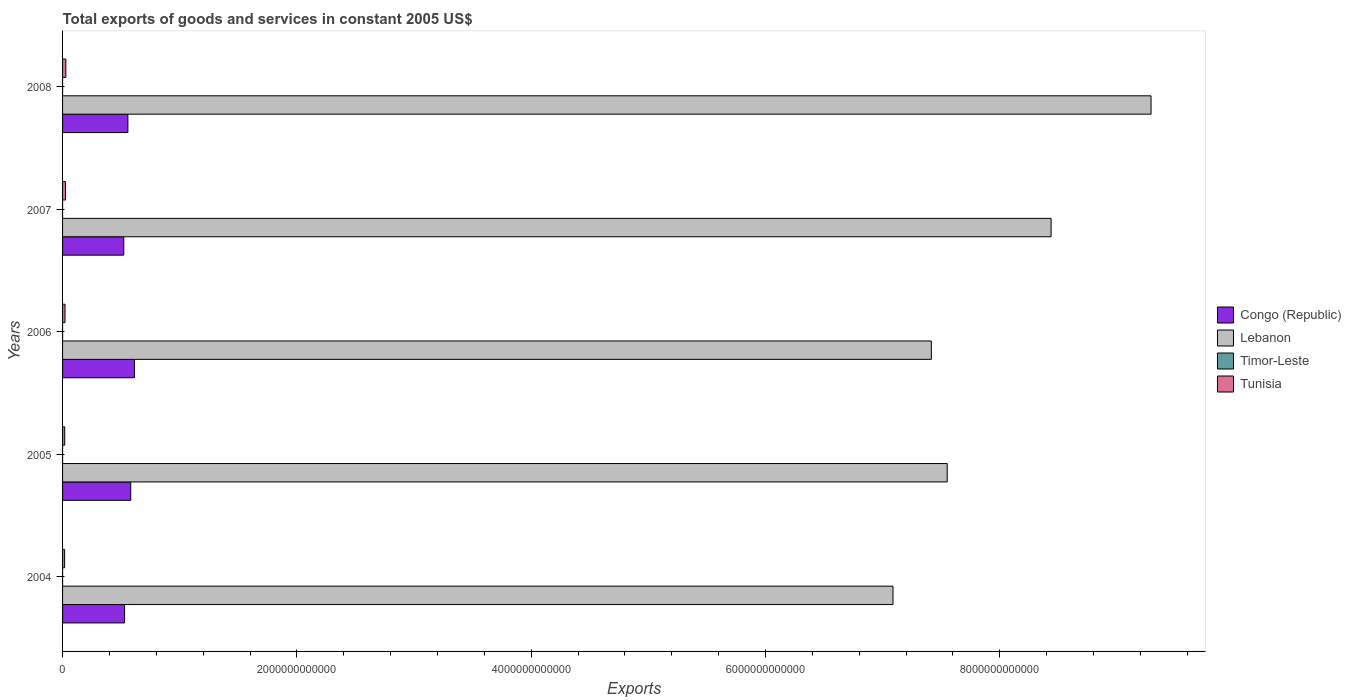How many bars are there on the 4th tick from the top?
Keep it short and to the point. 4. How many bars are there on the 2nd tick from the bottom?
Offer a very short reply. 4. What is the label of the 5th group of bars from the top?
Keep it short and to the point. 2004. What is the total exports of goods and services in Timor-Leste in 2008?
Offer a terse response. 6.50e+07. Across all years, what is the maximum total exports of goods and services in Tunisia?
Your answer should be very brief. 2.80e+1. Across all years, what is the minimum total exports of goods and services in Lebanon?
Ensure brevity in your answer.  7.09e+12. In which year was the total exports of goods and services in Congo (Republic) maximum?
Keep it short and to the point. 2006. In which year was the total exports of goods and services in Lebanon minimum?
Offer a terse response. 2004. What is the total total exports of goods and services in Lebanon in the graph?
Keep it short and to the point. 3.98e+13. What is the difference between the total exports of goods and services in Tunisia in 2007 and that in 2008?
Your answer should be compact. -2.82e+09. What is the difference between the total exports of goods and services in Tunisia in 2004 and the total exports of goods and services in Congo (Republic) in 2006?
Offer a terse response. -5.96e+11. What is the average total exports of goods and services in Timor-Leste per year?
Your answer should be very brief. 5.54e+07. In the year 2007, what is the difference between the total exports of goods and services in Congo (Republic) and total exports of goods and services in Tunisia?
Make the answer very short. 4.97e+11. What is the ratio of the total exports of goods and services in Tunisia in 2004 to that in 2007?
Your answer should be compact. 0.7. Is the difference between the total exports of goods and services in Congo (Republic) in 2004 and 2008 greater than the difference between the total exports of goods and services in Tunisia in 2004 and 2008?
Provide a short and direct response. No. What is the difference between the highest and the lowest total exports of goods and services in Congo (Republic)?
Offer a very short reply. 9.11e+1. In how many years, is the total exports of goods and services in Congo (Republic) greater than the average total exports of goods and services in Congo (Republic) taken over all years?
Offer a very short reply. 2. Is it the case that in every year, the sum of the total exports of goods and services in Lebanon and total exports of goods and services in Congo (Republic) is greater than the sum of total exports of goods and services in Timor-Leste and total exports of goods and services in Tunisia?
Give a very brief answer. Yes. What does the 2nd bar from the top in 2004 represents?
Provide a short and direct response. Timor-Leste. What does the 4th bar from the bottom in 2008 represents?
Your response must be concise. Tunisia. Are all the bars in the graph horizontal?
Offer a very short reply. Yes. What is the difference between two consecutive major ticks on the X-axis?
Ensure brevity in your answer.  2.00e+12. Are the values on the major ticks of X-axis written in scientific E-notation?
Ensure brevity in your answer.  No. Does the graph contain grids?
Provide a short and direct response. No. Where does the legend appear in the graph?
Ensure brevity in your answer.  Center right. How are the legend labels stacked?
Ensure brevity in your answer.  Vertical. What is the title of the graph?
Your answer should be very brief. Total exports of goods and services in constant 2005 US$. What is the label or title of the X-axis?
Offer a terse response. Exports. What is the label or title of the Y-axis?
Provide a succinct answer. Years. What is the Exports of Congo (Republic) in 2004?
Your answer should be compact. 5.29e+11. What is the Exports in Lebanon in 2004?
Keep it short and to the point. 7.09e+12. What is the Exports of Timor-Leste in 2004?
Keep it short and to the point. 5.10e+07. What is the Exports of Tunisia in 2004?
Provide a short and direct response. 1.75e+1. What is the Exports of Congo (Republic) in 2005?
Your response must be concise. 5.82e+11. What is the Exports in Lebanon in 2005?
Your response must be concise. 7.55e+12. What is the Exports in Timor-Leste in 2005?
Your response must be concise. 4.80e+07. What is the Exports of Tunisia in 2005?
Offer a very short reply. 1.83e+1. What is the Exports of Congo (Republic) in 2006?
Your response must be concise. 6.13e+11. What is the Exports in Lebanon in 2006?
Offer a terse response. 7.42e+12. What is the Exports of Timor-Leste in 2006?
Offer a terse response. 4.90e+07. What is the Exports in Tunisia in 2006?
Your answer should be compact. 2.10e+1. What is the Exports of Congo (Republic) in 2007?
Your answer should be compact. 5.22e+11. What is the Exports of Lebanon in 2007?
Make the answer very short. 8.44e+12. What is the Exports of Timor-Leste in 2007?
Offer a very short reply. 6.40e+07. What is the Exports of Tunisia in 2007?
Keep it short and to the point. 2.51e+1. What is the Exports in Congo (Republic) in 2008?
Offer a very short reply. 5.58e+11. What is the Exports in Lebanon in 2008?
Offer a terse response. 9.29e+12. What is the Exports of Timor-Leste in 2008?
Provide a short and direct response. 6.50e+07. What is the Exports of Tunisia in 2008?
Give a very brief answer. 2.80e+1. Across all years, what is the maximum Exports in Congo (Republic)?
Provide a succinct answer. 6.13e+11. Across all years, what is the maximum Exports of Lebanon?
Give a very brief answer. 9.29e+12. Across all years, what is the maximum Exports of Timor-Leste?
Keep it short and to the point. 6.50e+07. Across all years, what is the maximum Exports of Tunisia?
Offer a very short reply. 2.80e+1. Across all years, what is the minimum Exports of Congo (Republic)?
Offer a terse response. 5.22e+11. Across all years, what is the minimum Exports in Lebanon?
Ensure brevity in your answer.  7.09e+12. Across all years, what is the minimum Exports in Timor-Leste?
Your response must be concise. 4.80e+07. Across all years, what is the minimum Exports of Tunisia?
Offer a terse response. 1.75e+1. What is the total Exports in Congo (Republic) in the graph?
Offer a very short reply. 2.80e+12. What is the total Exports in Lebanon in the graph?
Your answer should be compact. 3.98e+13. What is the total Exports in Timor-Leste in the graph?
Your answer should be compact. 2.77e+08. What is the total Exports of Tunisia in the graph?
Provide a succinct answer. 1.10e+11. What is the difference between the Exports in Congo (Republic) in 2004 and that in 2005?
Give a very brief answer. -5.25e+1. What is the difference between the Exports in Lebanon in 2004 and that in 2005?
Your response must be concise. -4.63e+11. What is the difference between the Exports of Timor-Leste in 2004 and that in 2005?
Your response must be concise. 3.00e+06. What is the difference between the Exports of Tunisia in 2004 and that in 2005?
Keep it short and to the point. -7.73e+08. What is the difference between the Exports in Congo (Republic) in 2004 and that in 2006?
Provide a short and direct response. -8.39e+1. What is the difference between the Exports of Lebanon in 2004 and that in 2006?
Provide a succinct answer. -3.27e+11. What is the difference between the Exports of Tunisia in 2004 and that in 2006?
Your answer should be compact. -3.45e+09. What is the difference between the Exports in Congo (Republic) in 2004 and that in 2007?
Provide a succinct answer. 7.19e+09. What is the difference between the Exports of Lebanon in 2004 and that in 2007?
Offer a very short reply. -1.35e+12. What is the difference between the Exports of Timor-Leste in 2004 and that in 2007?
Offer a very short reply. -1.30e+07. What is the difference between the Exports of Tunisia in 2004 and that in 2007?
Your response must be concise. -7.63e+09. What is the difference between the Exports in Congo (Republic) in 2004 and that in 2008?
Make the answer very short. -2.81e+1. What is the difference between the Exports of Lebanon in 2004 and that in 2008?
Give a very brief answer. -2.20e+12. What is the difference between the Exports of Timor-Leste in 2004 and that in 2008?
Your answer should be very brief. -1.40e+07. What is the difference between the Exports in Tunisia in 2004 and that in 2008?
Your answer should be very brief. -1.04e+1. What is the difference between the Exports in Congo (Republic) in 2005 and that in 2006?
Your answer should be compact. -3.14e+1. What is the difference between the Exports in Lebanon in 2005 and that in 2006?
Keep it short and to the point. 1.36e+11. What is the difference between the Exports in Timor-Leste in 2005 and that in 2006?
Your answer should be very brief. -1.00e+06. What is the difference between the Exports in Tunisia in 2005 and that in 2006?
Give a very brief answer. -2.67e+09. What is the difference between the Exports in Congo (Republic) in 2005 and that in 2007?
Your response must be concise. 5.97e+1. What is the difference between the Exports of Lebanon in 2005 and that in 2007?
Make the answer very short. -8.87e+11. What is the difference between the Exports of Timor-Leste in 2005 and that in 2007?
Your response must be concise. -1.60e+07. What is the difference between the Exports of Tunisia in 2005 and that in 2007?
Ensure brevity in your answer.  -6.86e+09. What is the difference between the Exports in Congo (Republic) in 2005 and that in 2008?
Your answer should be very brief. 2.44e+1. What is the difference between the Exports in Lebanon in 2005 and that in 2008?
Give a very brief answer. -1.74e+12. What is the difference between the Exports in Timor-Leste in 2005 and that in 2008?
Your response must be concise. -1.70e+07. What is the difference between the Exports of Tunisia in 2005 and that in 2008?
Keep it short and to the point. -9.67e+09. What is the difference between the Exports in Congo (Republic) in 2006 and that in 2007?
Give a very brief answer. 9.11e+1. What is the difference between the Exports in Lebanon in 2006 and that in 2007?
Make the answer very short. -1.02e+12. What is the difference between the Exports in Timor-Leste in 2006 and that in 2007?
Your answer should be compact. -1.50e+07. What is the difference between the Exports of Tunisia in 2006 and that in 2007?
Make the answer very short. -4.19e+09. What is the difference between the Exports of Congo (Republic) in 2006 and that in 2008?
Offer a terse response. 5.58e+1. What is the difference between the Exports in Lebanon in 2006 and that in 2008?
Provide a succinct answer. -1.88e+12. What is the difference between the Exports in Timor-Leste in 2006 and that in 2008?
Keep it short and to the point. -1.60e+07. What is the difference between the Exports of Tunisia in 2006 and that in 2008?
Offer a very short reply. -7.00e+09. What is the difference between the Exports of Congo (Republic) in 2007 and that in 2008?
Your answer should be very brief. -3.53e+1. What is the difference between the Exports of Lebanon in 2007 and that in 2008?
Your response must be concise. -8.53e+11. What is the difference between the Exports of Tunisia in 2007 and that in 2008?
Your response must be concise. -2.82e+09. What is the difference between the Exports of Congo (Republic) in 2004 and the Exports of Lebanon in 2005?
Make the answer very short. -7.02e+12. What is the difference between the Exports of Congo (Republic) in 2004 and the Exports of Timor-Leste in 2005?
Make the answer very short. 5.29e+11. What is the difference between the Exports of Congo (Republic) in 2004 and the Exports of Tunisia in 2005?
Offer a very short reply. 5.11e+11. What is the difference between the Exports in Lebanon in 2004 and the Exports in Timor-Leste in 2005?
Your answer should be very brief. 7.09e+12. What is the difference between the Exports in Lebanon in 2004 and the Exports in Tunisia in 2005?
Make the answer very short. 7.07e+12. What is the difference between the Exports of Timor-Leste in 2004 and the Exports of Tunisia in 2005?
Ensure brevity in your answer.  -1.82e+1. What is the difference between the Exports in Congo (Republic) in 2004 and the Exports in Lebanon in 2006?
Offer a terse response. -6.89e+12. What is the difference between the Exports of Congo (Republic) in 2004 and the Exports of Timor-Leste in 2006?
Your response must be concise. 5.29e+11. What is the difference between the Exports of Congo (Republic) in 2004 and the Exports of Tunisia in 2006?
Provide a short and direct response. 5.08e+11. What is the difference between the Exports in Lebanon in 2004 and the Exports in Timor-Leste in 2006?
Make the answer very short. 7.09e+12. What is the difference between the Exports in Lebanon in 2004 and the Exports in Tunisia in 2006?
Your answer should be very brief. 7.07e+12. What is the difference between the Exports in Timor-Leste in 2004 and the Exports in Tunisia in 2006?
Your answer should be very brief. -2.09e+1. What is the difference between the Exports in Congo (Republic) in 2004 and the Exports in Lebanon in 2007?
Offer a very short reply. -7.91e+12. What is the difference between the Exports of Congo (Republic) in 2004 and the Exports of Timor-Leste in 2007?
Offer a terse response. 5.29e+11. What is the difference between the Exports in Congo (Republic) in 2004 and the Exports in Tunisia in 2007?
Your response must be concise. 5.04e+11. What is the difference between the Exports of Lebanon in 2004 and the Exports of Timor-Leste in 2007?
Offer a very short reply. 7.09e+12. What is the difference between the Exports in Lebanon in 2004 and the Exports in Tunisia in 2007?
Make the answer very short. 7.06e+12. What is the difference between the Exports in Timor-Leste in 2004 and the Exports in Tunisia in 2007?
Keep it short and to the point. -2.51e+1. What is the difference between the Exports of Congo (Republic) in 2004 and the Exports of Lebanon in 2008?
Your response must be concise. -8.76e+12. What is the difference between the Exports in Congo (Republic) in 2004 and the Exports in Timor-Leste in 2008?
Offer a very short reply. 5.29e+11. What is the difference between the Exports of Congo (Republic) in 2004 and the Exports of Tunisia in 2008?
Make the answer very short. 5.01e+11. What is the difference between the Exports in Lebanon in 2004 and the Exports in Timor-Leste in 2008?
Keep it short and to the point. 7.09e+12. What is the difference between the Exports of Lebanon in 2004 and the Exports of Tunisia in 2008?
Offer a very short reply. 7.06e+12. What is the difference between the Exports in Timor-Leste in 2004 and the Exports in Tunisia in 2008?
Provide a short and direct response. -2.79e+1. What is the difference between the Exports in Congo (Republic) in 2005 and the Exports in Lebanon in 2006?
Your answer should be very brief. -6.83e+12. What is the difference between the Exports of Congo (Republic) in 2005 and the Exports of Timor-Leste in 2006?
Your answer should be very brief. 5.82e+11. What is the difference between the Exports of Congo (Republic) in 2005 and the Exports of Tunisia in 2006?
Your response must be concise. 5.61e+11. What is the difference between the Exports of Lebanon in 2005 and the Exports of Timor-Leste in 2006?
Offer a very short reply. 7.55e+12. What is the difference between the Exports of Lebanon in 2005 and the Exports of Tunisia in 2006?
Make the answer very short. 7.53e+12. What is the difference between the Exports of Timor-Leste in 2005 and the Exports of Tunisia in 2006?
Provide a succinct answer. -2.09e+1. What is the difference between the Exports in Congo (Republic) in 2005 and the Exports in Lebanon in 2007?
Provide a short and direct response. -7.86e+12. What is the difference between the Exports in Congo (Republic) in 2005 and the Exports in Timor-Leste in 2007?
Provide a short and direct response. 5.82e+11. What is the difference between the Exports of Congo (Republic) in 2005 and the Exports of Tunisia in 2007?
Offer a terse response. 5.57e+11. What is the difference between the Exports in Lebanon in 2005 and the Exports in Timor-Leste in 2007?
Provide a short and direct response. 7.55e+12. What is the difference between the Exports of Lebanon in 2005 and the Exports of Tunisia in 2007?
Make the answer very short. 7.53e+12. What is the difference between the Exports of Timor-Leste in 2005 and the Exports of Tunisia in 2007?
Provide a short and direct response. -2.51e+1. What is the difference between the Exports of Congo (Republic) in 2005 and the Exports of Lebanon in 2008?
Provide a short and direct response. -8.71e+12. What is the difference between the Exports of Congo (Republic) in 2005 and the Exports of Timor-Leste in 2008?
Keep it short and to the point. 5.82e+11. What is the difference between the Exports of Congo (Republic) in 2005 and the Exports of Tunisia in 2008?
Make the answer very short. 5.54e+11. What is the difference between the Exports of Lebanon in 2005 and the Exports of Timor-Leste in 2008?
Make the answer very short. 7.55e+12. What is the difference between the Exports of Lebanon in 2005 and the Exports of Tunisia in 2008?
Your answer should be very brief. 7.52e+12. What is the difference between the Exports of Timor-Leste in 2005 and the Exports of Tunisia in 2008?
Ensure brevity in your answer.  -2.79e+1. What is the difference between the Exports in Congo (Republic) in 2006 and the Exports in Lebanon in 2007?
Your answer should be compact. -7.82e+12. What is the difference between the Exports of Congo (Republic) in 2006 and the Exports of Timor-Leste in 2007?
Provide a short and direct response. 6.13e+11. What is the difference between the Exports in Congo (Republic) in 2006 and the Exports in Tunisia in 2007?
Your answer should be very brief. 5.88e+11. What is the difference between the Exports in Lebanon in 2006 and the Exports in Timor-Leste in 2007?
Offer a very short reply. 7.42e+12. What is the difference between the Exports of Lebanon in 2006 and the Exports of Tunisia in 2007?
Your answer should be very brief. 7.39e+12. What is the difference between the Exports in Timor-Leste in 2006 and the Exports in Tunisia in 2007?
Keep it short and to the point. -2.51e+1. What is the difference between the Exports in Congo (Republic) in 2006 and the Exports in Lebanon in 2008?
Offer a very short reply. -8.68e+12. What is the difference between the Exports in Congo (Republic) in 2006 and the Exports in Timor-Leste in 2008?
Make the answer very short. 6.13e+11. What is the difference between the Exports of Congo (Republic) in 2006 and the Exports of Tunisia in 2008?
Make the answer very short. 5.85e+11. What is the difference between the Exports of Lebanon in 2006 and the Exports of Timor-Leste in 2008?
Ensure brevity in your answer.  7.42e+12. What is the difference between the Exports in Lebanon in 2006 and the Exports in Tunisia in 2008?
Keep it short and to the point. 7.39e+12. What is the difference between the Exports in Timor-Leste in 2006 and the Exports in Tunisia in 2008?
Provide a succinct answer. -2.79e+1. What is the difference between the Exports of Congo (Republic) in 2007 and the Exports of Lebanon in 2008?
Your response must be concise. -8.77e+12. What is the difference between the Exports of Congo (Republic) in 2007 and the Exports of Timor-Leste in 2008?
Provide a succinct answer. 5.22e+11. What is the difference between the Exports of Congo (Republic) in 2007 and the Exports of Tunisia in 2008?
Make the answer very short. 4.94e+11. What is the difference between the Exports of Lebanon in 2007 and the Exports of Timor-Leste in 2008?
Keep it short and to the point. 8.44e+12. What is the difference between the Exports of Lebanon in 2007 and the Exports of Tunisia in 2008?
Ensure brevity in your answer.  8.41e+12. What is the difference between the Exports of Timor-Leste in 2007 and the Exports of Tunisia in 2008?
Give a very brief answer. -2.79e+1. What is the average Exports in Congo (Republic) per year?
Offer a very short reply. 5.61e+11. What is the average Exports in Lebanon per year?
Offer a very short reply. 7.96e+12. What is the average Exports of Timor-Leste per year?
Your answer should be very brief. 5.54e+07. What is the average Exports of Tunisia per year?
Give a very brief answer. 2.20e+1. In the year 2004, what is the difference between the Exports of Congo (Republic) and Exports of Lebanon?
Make the answer very short. -6.56e+12. In the year 2004, what is the difference between the Exports of Congo (Republic) and Exports of Timor-Leste?
Make the answer very short. 5.29e+11. In the year 2004, what is the difference between the Exports of Congo (Republic) and Exports of Tunisia?
Offer a very short reply. 5.12e+11. In the year 2004, what is the difference between the Exports of Lebanon and Exports of Timor-Leste?
Keep it short and to the point. 7.09e+12. In the year 2004, what is the difference between the Exports in Lebanon and Exports in Tunisia?
Offer a terse response. 7.07e+12. In the year 2004, what is the difference between the Exports in Timor-Leste and Exports in Tunisia?
Make the answer very short. -1.75e+1. In the year 2005, what is the difference between the Exports of Congo (Republic) and Exports of Lebanon?
Offer a terse response. -6.97e+12. In the year 2005, what is the difference between the Exports of Congo (Republic) and Exports of Timor-Leste?
Ensure brevity in your answer.  5.82e+11. In the year 2005, what is the difference between the Exports in Congo (Republic) and Exports in Tunisia?
Keep it short and to the point. 5.64e+11. In the year 2005, what is the difference between the Exports in Lebanon and Exports in Timor-Leste?
Offer a terse response. 7.55e+12. In the year 2005, what is the difference between the Exports in Lebanon and Exports in Tunisia?
Keep it short and to the point. 7.53e+12. In the year 2005, what is the difference between the Exports of Timor-Leste and Exports of Tunisia?
Offer a terse response. -1.82e+1. In the year 2006, what is the difference between the Exports in Congo (Republic) and Exports in Lebanon?
Offer a terse response. -6.80e+12. In the year 2006, what is the difference between the Exports of Congo (Republic) and Exports of Timor-Leste?
Make the answer very short. 6.13e+11. In the year 2006, what is the difference between the Exports in Congo (Republic) and Exports in Tunisia?
Your answer should be compact. 5.92e+11. In the year 2006, what is the difference between the Exports in Lebanon and Exports in Timor-Leste?
Give a very brief answer. 7.42e+12. In the year 2006, what is the difference between the Exports of Lebanon and Exports of Tunisia?
Your answer should be compact. 7.40e+12. In the year 2006, what is the difference between the Exports of Timor-Leste and Exports of Tunisia?
Provide a succinct answer. -2.09e+1. In the year 2007, what is the difference between the Exports of Congo (Republic) and Exports of Lebanon?
Give a very brief answer. -7.92e+12. In the year 2007, what is the difference between the Exports of Congo (Republic) and Exports of Timor-Leste?
Make the answer very short. 5.22e+11. In the year 2007, what is the difference between the Exports of Congo (Republic) and Exports of Tunisia?
Your answer should be compact. 4.97e+11. In the year 2007, what is the difference between the Exports in Lebanon and Exports in Timor-Leste?
Your response must be concise. 8.44e+12. In the year 2007, what is the difference between the Exports in Lebanon and Exports in Tunisia?
Keep it short and to the point. 8.41e+12. In the year 2007, what is the difference between the Exports in Timor-Leste and Exports in Tunisia?
Your answer should be very brief. -2.51e+1. In the year 2008, what is the difference between the Exports in Congo (Republic) and Exports in Lebanon?
Ensure brevity in your answer.  -8.73e+12. In the year 2008, what is the difference between the Exports of Congo (Republic) and Exports of Timor-Leste?
Provide a succinct answer. 5.58e+11. In the year 2008, what is the difference between the Exports of Congo (Republic) and Exports of Tunisia?
Make the answer very short. 5.30e+11. In the year 2008, what is the difference between the Exports of Lebanon and Exports of Timor-Leste?
Your response must be concise. 9.29e+12. In the year 2008, what is the difference between the Exports of Lebanon and Exports of Tunisia?
Make the answer very short. 9.26e+12. In the year 2008, what is the difference between the Exports in Timor-Leste and Exports in Tunisia?
Make the answer very short. -2.79e+1. What is the ratio of the Exports of Congo (Republic) in 2004 to that in 2005?
Make the answer very short. 0.91. What is the ratio of the Exports of Lebanon in 2004 to that in 2005?
Provide a succinct answer. 0.94. What is the ratio of the Exports of Tunisia in 2004 to that in 2005?
Offer a terse response. 0.96. What is the ratio of the Exports of Congo (Republic) in 2004 to that in 2006?
Offer a very short reply. 0.86. What is the ratio of the Exports of Lebanon in 2004 to that in 2006?
Give a very brief answer. 0.96. What is the ratio of the Exports in Timor-Leste in 2004 to that in 2006?
Ensure brevity in your answer.  1.04. What is the ratio of the Exports in Tunisia in 2004 to that in 2006?
Provide a succinct answer. 0.84. What is the ratio of the Exports in Congo (Republic) in 2004 to that in 2007?
Offer a terse response. 1.01. What is the ratio of the Exports of Lebanon in 2004 to that in 2007?
Your answer should be very brief. 0.84. What is the ratio of the Exports of Timor-Leste in 2004 to that in 2007?
Keep it short and to the point. 0.8. What is the ratio of the Exports in Tunisia in 2004 to that in 2007?
Offer a very short reply. 0.7. What is the ratio of the Exports in Congo (Republic) in 2004 to that in 2008?
Make the answer very short. 0.95. What is the ratio of the Exports in Lebanon in 2004 to that in 2008?
Provide a succinct answer. 0.76. What is the ratio of the Exports of Timor-Leste in 2004 to that in 2008?
Provide a succinct answer. 0.78. What is the ratio of the Exports of Tunisia in 2004 to that in 2008?
Your answer should be compact. 0.63. What is the ratio of the Exports of Congo (Republic) in 2005 to that in 2006?
Provide a succinct answer. 0.95. What is the ratio of the Exports in Lebanon in 2005 to that in 2006?
Offer a very short reply. 1.02. What is the ratio of the Exports in Timor-Leste in 2005 to that in 2006?
Offer a very short reply. 0.98. What is the ratio of the Exports in Tunisia in 2005 to that in 2006?
Provide a succinct answer. 0.87. What is the ratio of the Exports in Congo (Republic) in 2005 to that in 2007?
Provide a short and direct response. 1.11. What is the ratio of the Exports in Lebanon in 2005 to that in 2007?
Your answer should be compact. 0.89. What is the ratio of the Exports in Timor-Leste in 2005 to that in 2007?
Give a very brief answer. 0.75. What is the ratio of the Exports in Tunisia in 2005 to that in 2007?
Provide a short and direct response. 0.73. What is the ratio of the Exports of Congo (Republic) in 2005 to that in 2008?
Offer a very short reply. 1.04. What is the ratio of the Exports in Lebanon in 2005 to that in 2008?
Your answer should be compact. 0.81. What is the ratio of the Exports in Timor-Leste in 2005 to that in 2008?
Give a very brief answer. 0.74. What is the ratio of the Exports in Tunisia in 2005 to that in 2008?
Give a very brief answer. 0.65. What is the ratio of the Exports in Congo (Republic) in 2006 to that in 2007?
Your response must be concise. 1.17. What is the ratio of the Exports in Lebanon in 2006 to that in 2007?
Make the answer very short. 0.88. What is the ratio of the Exports in Timor-Leste in 2006 to that in 2007?
Provide a short and direct response. 0.77. What is the ratio of the Exports in Tunisia in 2006 to that in 2007?
Make the answer very short. 0.83. What is the ratio of the Exports of Lebanon in 2006 to that in 2008?
Provide a succinct answer. 0.8. What is the ratio of the Exports of Timor-Leste in 2006 to that in 2008?
Give a very brief answer. 0.75. What is the ratio of the Exports in Tunisia in 2006 to that in 2008?
Your answer should be compact. 0.75. What is the ratio of the Exports of Congo (Republic) in 2007 to that in 2008?
Give a very brief answer. 0.94. What is the ratio of the Exports in Lebanon in 2007 to that in 2008?
Give a very brief answer. 0.91. What is the ratio of the Exports of Timor-Leste in 2007 to that in 2008?
Offer a very short reply. 0.98. What is the ratio of the Exports in Tunisia in 2007 to that in 2008?
Your response must be concise. 0.9. What is the difference between the highest and the second highest Exports in Congo (Republic)?
Your answer should be compact. 3.14e+1. What is the difference between the highest and the second highest Exports in Lebanon?
Ensure brevity in your answer.  8.53e+11. What is the difference between the highest and the second highest Exports in Tunisia?
Your answer should be compact. 2.82e+09. What is the difference between the highest and the lowest Exports of Congo (Republic)?
Give a very brief answer. 9.11e+1. What is the difference between the highest and the lowest Exports in Lebanon?
Your answer should be very brief. 2.20e+12. What is the difference between the highest and the lowest Exports of Timor-Leste?
Your response must be concise. 1.70e+07. What is the difference between the highest and the lowest Exports in Tunisia?
Give a very brief answer. 1.04e+1. 